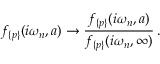Convert formula to latex. <formula><loc_0><loc_0><loc_500><loc_500>f _ { \{ p \} } ( i \omega _ { n } , a ) \to \frac { f _ { \{ p \} } ( i \omega _ { n } , a ) } { f _ { \{ p \} } ( i \omega _ { n } , \infty ) } \, { . }</formula> 